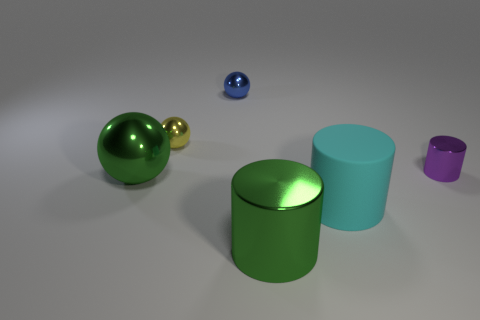There is a big metallic thing right of the large green ball; does it have the same color as the large ball?
Ensure brevity in your answer.  Yes. Are there any other things that have the same material as the cyan cylinder?
Give a very brief answer. No. What number of blue metal objects have the same shape as the cyan object?
Ensure brevity in your answer.  0. There is a green sphere that is the same material as the tiny yellow sphere; what size is it?
Your answer should be very brief. Large. Are there any objects that are in front of the tiny metallic object that is to the right of the metallic object that is in front of the large matte cylinder?
Provide a succinct answer. Yes. Is the size of the metal ball to the right of the yellow shiny object the same as the tiny shiny cylinder?
Give a very brief answer. Yes. How many blue balls have the same size as the blue object?
Keep it short and to the point. 0. What size is the shiny cylinder that is the same color as the big shiny sphere?
Keep it short and to the point. Large. Is the large ball the same color as the big metallic cylinder?
Make the answer very short. Yes. What is the shape of the small yellow metallic thing?
Offer a very short reply. Sphere. 